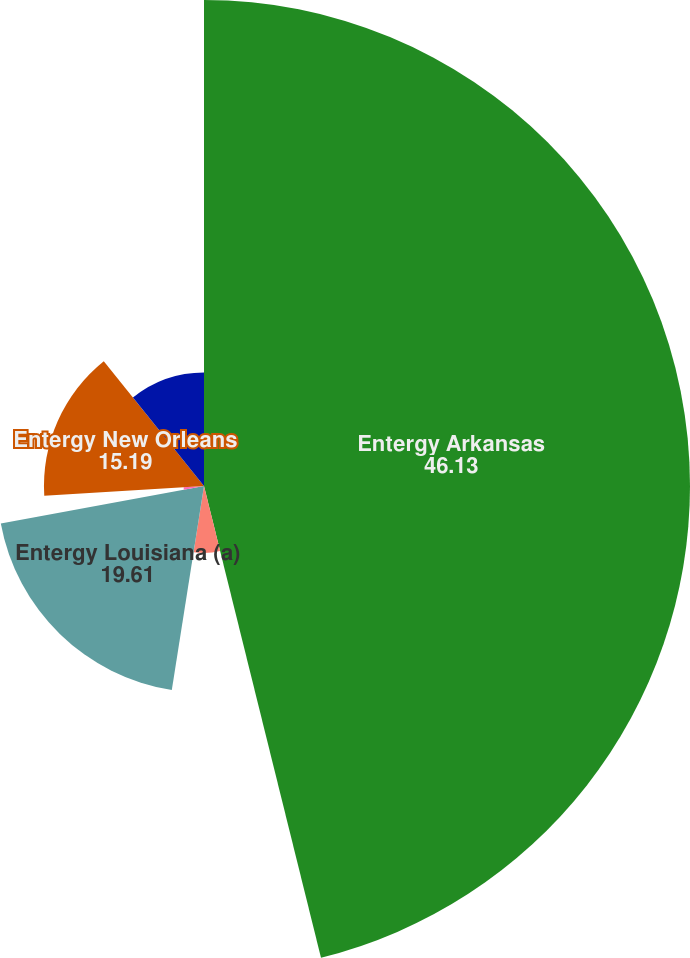<chart> <loc_0><loc_0><loc_500><loc_500><pie_chart><fcel>Entergy Arkansas<fcel>Entergy Gulf States Louisiana<fcel>Entergy Louisiana (a)<fcel>Entergy Mississippi<fcel>Entergy New Orleans<fcel>Entergy Texas<nl><fcel>46.13%<fcel>6.36%<fcel>19.61%<fcel>1.94%<fcel>15.19%<fcel>10.77%<nl></chart> 